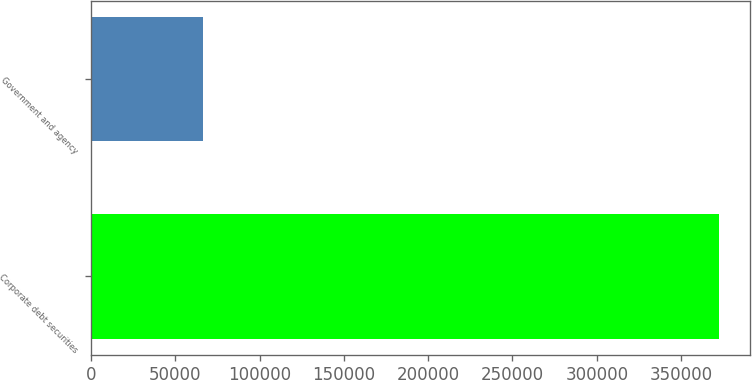Convert chart. <chart><loc_0><loc_0><loc_500><loc_500><bar_chart><fcel>Corporate debt securities<fcel>Government and agency<nl><fcel>372225<fcel>66534<nl></chart> 